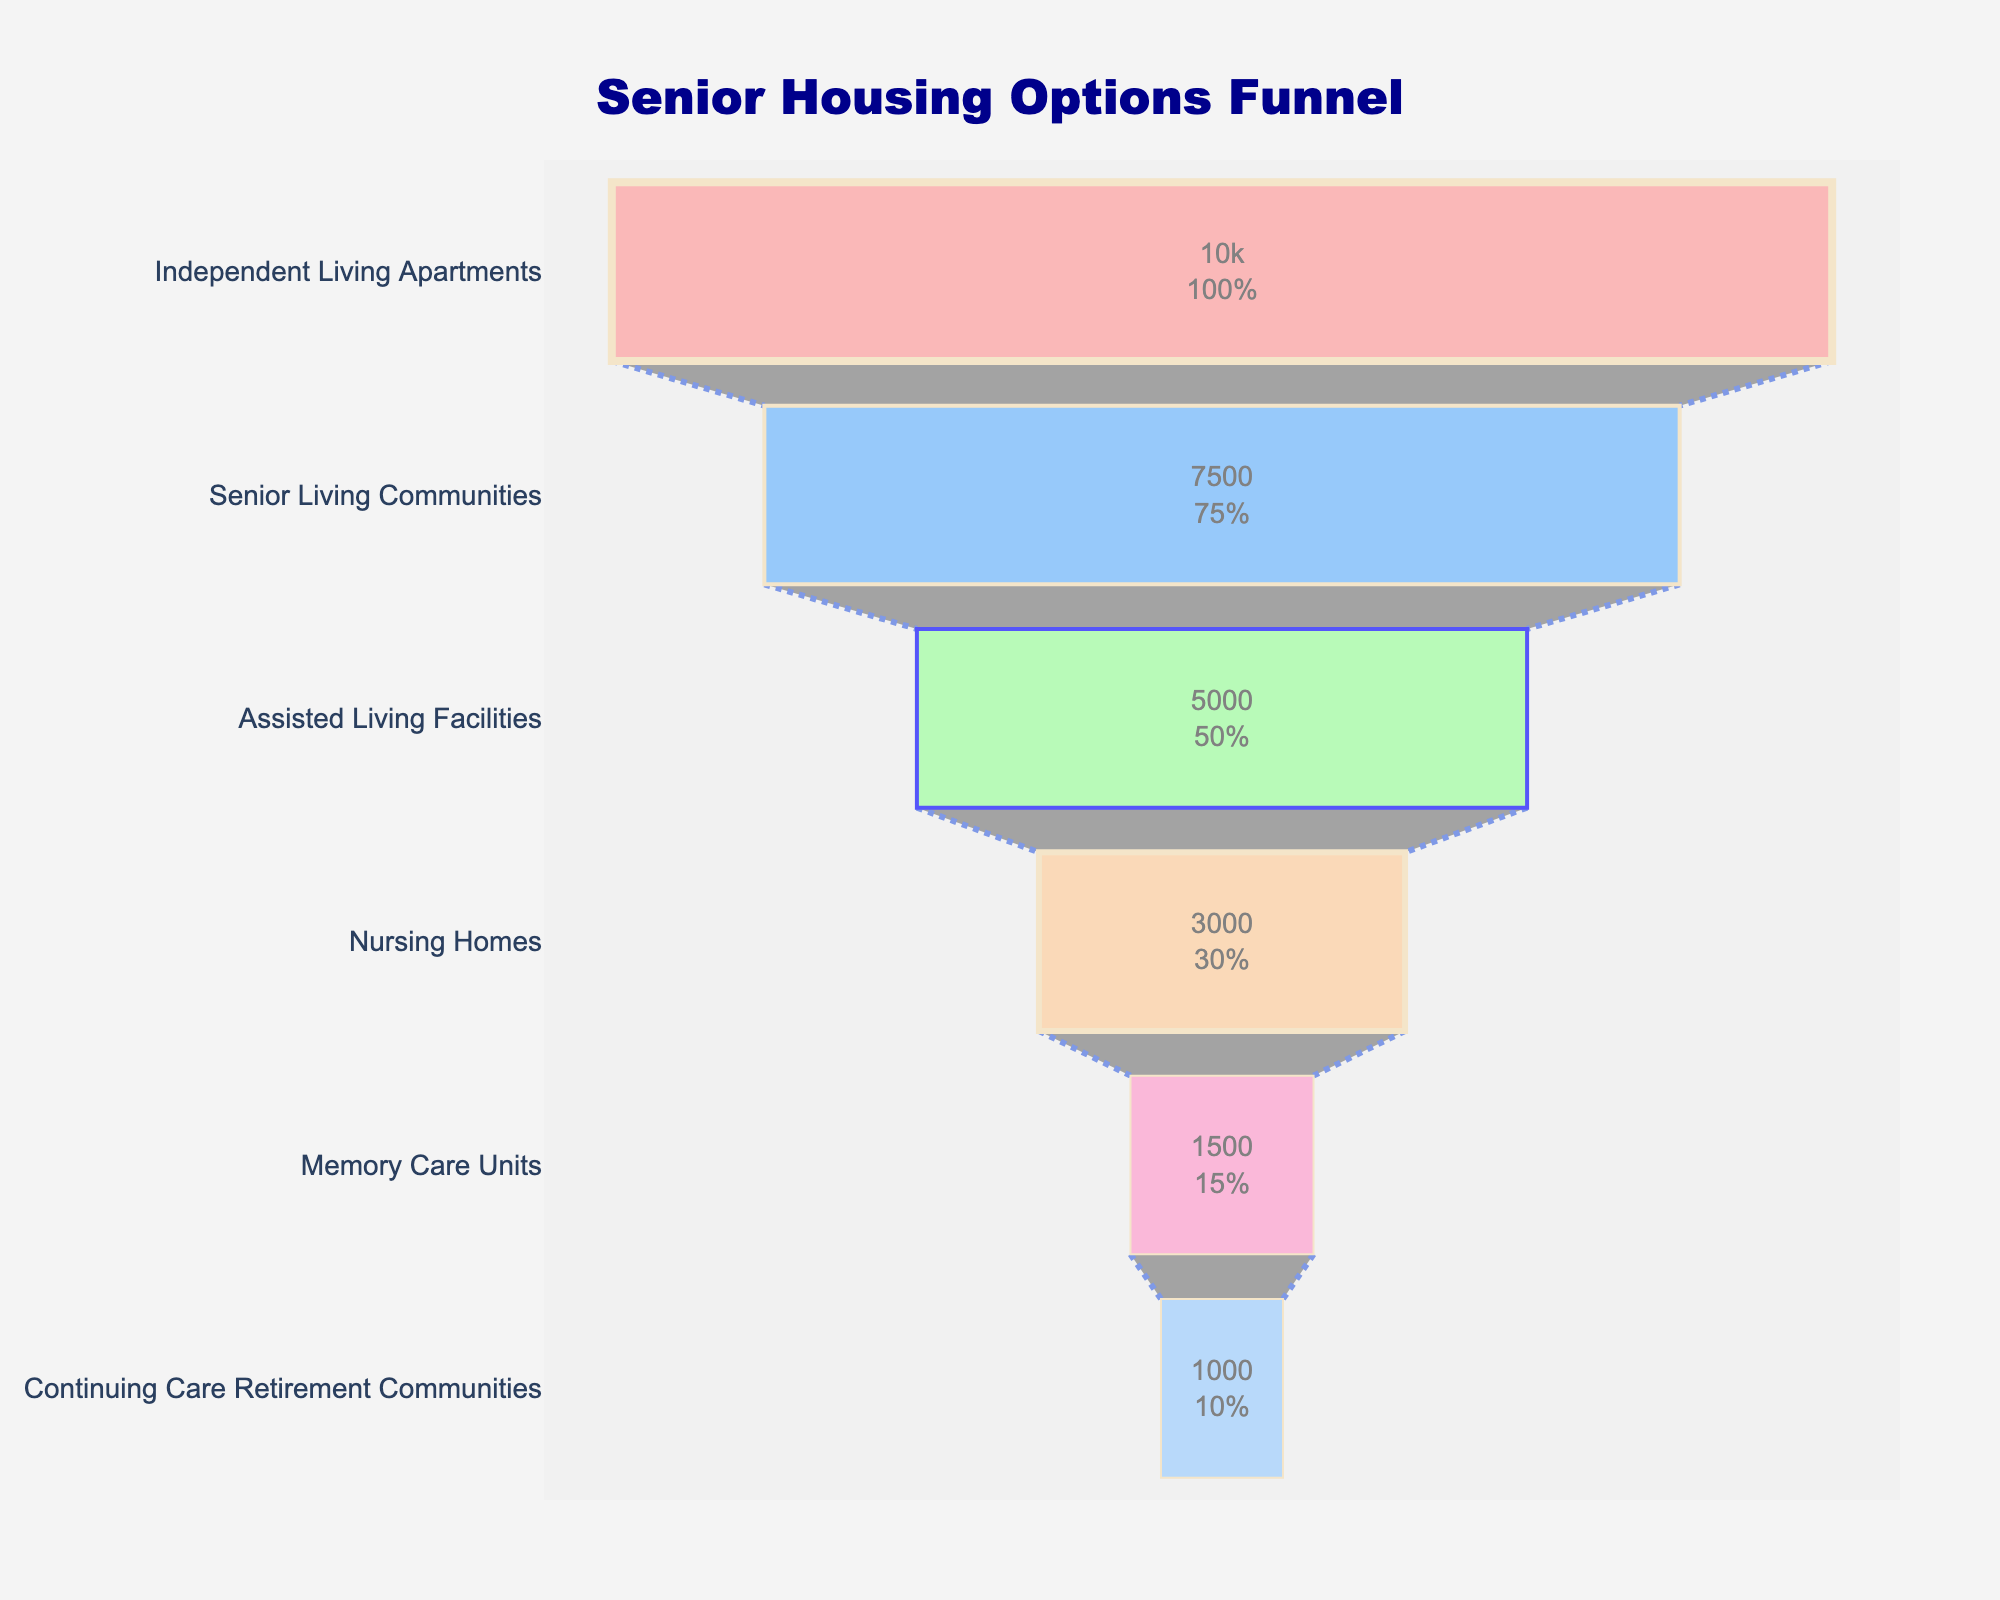What's the title of the chart? The chart's title is usually prominently displayed at the top. Here, it reads "Senior Housing Options Funnel".
Answer: Senior Housing Options Funnel How many stages are depicted in the chart? By counting the distinct segments or labels in the chart, you can see there are 6 stages.
Answer: 6 Which stage has the highest number of seniors? By looking at the largest segment in the funnel chart, the "Independent Living Apartments" stage is at the widest part of the funnel, indicating the highest number of seniors.
Answer: Independent Living Apartments What's the difference in the number of seniors between Senior Living Communities and Continuing Care Retirement Communities? Subtract the number of seniors in "Continuing Care Retirement Communities" (1000) from the number in "Senior Living Communities" (7500). The difference is 7500 - 1000.
Answer: 6500 Which two stages combined have close to the same number of seniors as Independent Living Apartments? Summing "Assisted Living Facilities" (5000) and "Senior Living Communities" (7500) gives 5000 + 7500 = 12500, which is not close. But, summing "Assisted Living Facilities" (5000) and "Nursing Homes" (3000) gives 5000 + 3000 = 8000, which is closer to 10000.
Answer: Assisted Living Facilities and Nursing Homes What percentage of seniors are in Independent Living Apartments compared to the initial number? The initial number is 10000 (Independent Living Apartments). Since it is the top of the funnel, it represents the baseline (100%).
Answer: 100% Is the number of seniors in Memory Care Units greater than those in Nursing Homes? Comparing the numbers, Memory Care Units have 1500 seniors, while Nursing Homes have 3000 seniors. So, Memory Care Units have fewer seniors.
Answer: No What is the total number of seniors in all the stages combined? Summing all the numbers: 10000 (Independent Living Apartments) + 7500 (Senior Living Communities) + 5000 (Assisted Living Facilities) + 3000 (Nursing Homes) + 1500 (Memory Care Units) + 1000 (Continuing Care Retirement Communities) = 28000.
Answer: 28000 Which stage shows a significant drop compared to the previous one? By comparing the numbers between consecutive stages, the change from "Independent Living Apartments" (10000) to "Senior Living Communities" (7500) is significant but the change from "Assisted Living Facilities" (5000) to "Nursing Homes" (3000) shows a noticeable drop of 2000.
Answer: Assisted Living Facilities to Nursing Homes How is the color and line width used to differentiate between stages in the chart? The stages use different colors with "Independent Living Apartments" having a distinctive color (e.g., light red) and the line width varies from thicker (4) at the top to thinner (1) at the bottom.
Answer: Colors and line widths 